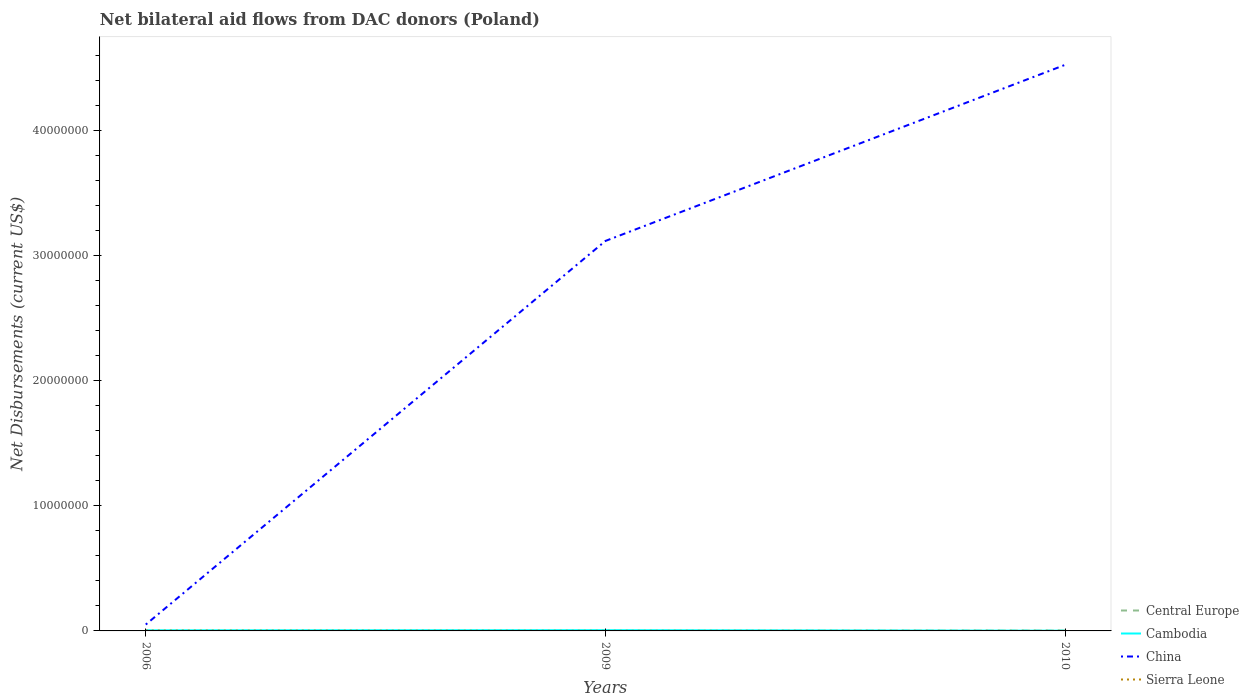How many different coloured lines are there?
Your answer should be compact. 4. Does the line corresponding to Cambodia intersect with the line corresponding to Central Europe?
Give a very brief answer. Yes. What is the total net bilateral aid flows in China in the graph?
Offer a very short reply. -1.41e+07. What is the difference between the highest and the second highest net bilateral aid flows in Cambodia?
Offer a very short reply. 4.00e+04. What is the difference between the highest and the lowest net bilateral aid flows in China?
Give a very brief answer. 2. How many lines are there?
Make the answer very short. 4. Are the values on the major ticks of Y-axis written in scientific E-notation?
Your response must be concise. No. Where does the legend appear in the graph?
Ensure brevity in your answer.  Bottom right. What is the title of the graph?
Ensure brevity in your answer.  Net bilateral aid flows from DAC donors (Poland). Does "Turks and Caicos Islands" appear as one of the legend labels in the graph?
Offer a terse response. No. What is the label or title of the Y-axis?
Give a very brief answer. Net Disbursements (current US$). What is the Net Disbursements (current US$) in Cambodia in 2006?
Give a very brief answer. 5.00e+04. What is the Net Disbursements (current US$) in China in 2006?
Offer a very short reply. 5.10e+05. What is the Net Disbursements (current US$) in Central Europe in 2009?
Your answer should be compact. 10000. What is the Net Disbursements (current US$) of China in 2009?
Your answer should be very brief. 3.12e+07. What is the Net Disbursements (current US$) of Central Europe in 2010?
Your answer should be compact. 3.00e+04. What is the Net Disbursements (current US$) in China in 2010?
Your answer should be very brief. 4.52e+07. What is the Net Disbursements (current US$) of Sierra Leone in 2010?
Give a very brief answer. 10000. Across all years, what is the maximum Net Disbursements (current US$) of China?
Provide a succinct answer. 4.52e+07. Across all years, what is the maximum Net Disbursements (current US$) of Sierra Leone?
Ensure brevity in your answer.  3.00e+04. Across all years, what is the minimum Net Disbursements (current US$) of Central Europe?
Your answer should be compact. 10000. Across all years, what is the minimum Net Disbursements (current US$) in China?
Your response must be concise. 5.10e+05. Across all years, what is the minimum Net Disbursements (current US$) in Sierra Leone?
Keep it short and to the point. 10000. What is the total Net Disbursements (current US$) of Central Europe in the graph?
Your answer should be compact. 5.00e+04. What is the total Net Disbursements (current US$) of Cambodia in the graph?
Offer a terse response. 1.30e+05. What is the total Net Disbursements (current US$) in China in the graph?
Provide a succinct answer. 7.69e+07. What is the total Net Disbursements (current US$) in Sierra Leone in the graph?
Your answer should be very brief. 5.00e+04. What is the difference between the Net Disbursements (current US$) in Cambodia in 2006 and that in 2009?
Give a very brief answer. -10000. What is the difference between the Net Disbursements (current US$) in China in 2006 and that in 2009?
Ensure brevity in your answer.  -3.06e+07. What is the difference between the Net Disbursements (current US$) of Cambodia in 2006 and that in 2010?
Your response must be concise. 3.00e+04. What is the difference between the Net Disbursements (current US$) in China in 2006 and that in 2010?
Offer a terse response. -4.47e+07. What is the difference between the Net Disbursements (current US$) in Central Europe in 2009 and that in 2010?
Make the answer very short. -2.00e+04. What is the difference between the Net Disbursements (current US$) in Cambodia in 2009 and that in 2010?
Offer a terse response. 4.00e+04. What is the difference between the Net Disbursements (current US$) in China in 2009 and that in 2010?
Give a very brief answer. -1.41e+07. What is the difference between the Net Disbursements (current US$) of Sierra Leone in 2009 and that in 2010?
Your answer should be compact. 0. What is the difference between the Net Disbursements (current US$) of Central Europe in 2006 and the Net Disbursements (current US$) of Cambodia in 2009?
Give a very brief answer. -5.00e+04. What is the difference between the Net Disbursements (current US$) of Central Europe in 2006 and the Net Disbursements (current US$) of China in 2009?
Keep it short and to the point. -3.12e+07. What is the difference between the Net Disbursements (current US$) in Cambodia in 2006 and the Net Disbursements (current US$) in China in 2009?
Offer a very short reply. -3.11e+07. What is the difference between the Net Disbursements (current US$) in Cambodia in 2006 and the Net Disbursements (current US$) in Sierra Leone in 2009?
Provide a succinct answer. 4.00e+04. What is the difference between the Net Disbursements (current US$) in China in 2006 and the Net Disbursements (current US$) in Sierra Leone in 2009?
Keep it short and to the point. 5.00e+05. What is the difference between the Net Disbursements (current US$) in Central Europe in 2006 and the Net Disbursements (current US$) in China in 2010?
Give a very brief answer. -4.52e+07. What is the difference between the Net Disbursements (current US$) of Central Europe in 2006 and the Net Disbursements (current US$) of Sierra Leone in 2010?
Your answer should be compact. 0. What is the difference between the Net Disbursements (current US$) in Cambodia in 2006 and the Net Disbursements (current US$) in China in 2010?
Offer a very short reply. -4.52e+07. What is the difference between the Net Disbursements (current US$) of Cambodia in 2006 and the Net Disbursements (current US$) of Sierra Leone in 2010?
Provide a short and direct response. 4.00e+04. What is the difference between the Net Disbursements (current US$) of China in 2006 and the Net Disbursements (current US$) of Sierra Leone in 2010?
Offer a very short reply. 5.00e+05. What is the difference between the Net Disbursements (current US$) of Central Europe in 2009 and the Net Disbursements (current US$) of China in 2010?
Provide a succinct answer. -4.52e+07. What is the difference between the Net Disbursements (current US$) in Central Europe in 2009 and the Net Disbursements (current US$) in Sierra Leone in 2010?
Provide a succinct answer. 0. What is the difference between the Net Disbursements (current US$) of Cambodia in 2009 and the Net Disbursements (current US$) of China in 2010?
Make the answer very short. -4.52e+07. What is the difference between the Net Disbursements (current US$) in China in 2009 and the Net Disbursements (current US$) in Sierra Leone in 2010?
Provide a succinct answer. 3.12e+07. What is the average Net Disbursements (current US$) of Central Europe per year?
Offer a very short reply. 1.67e+04. What is the average Net Disbursements (current US$) in Cambodia per year?
Offer a terse response. 4.33e+04. What is the average Net Disbursements (current US$) of China per year?
Make the answer very short. 2.56e+07. What is the average Net Disbursements (current US$) in Sierra Leone per year?
Keep it short and to the point. 1.67e+04. In the year 2006, what is the difference between the Net Disbursements (current US$) in Central Europe and Net Disbursements (current US$) in Cambodia?
Make the answer very short. -4.00e+04. In the year 2006, what is the difference between the Net Disbursements (current US$) in Central Europe and Net Disbursements (current US$) in China?
Your response must be concise. -5.00e+05. In the year 2006, what is the difference between the Net Disbursements (current US$) in Central Europe and Net Disbursements (current US$) in Sierra Leone?
Provide a succinct answer. -2.00e+04. In the year 2006, what is the difference between the Net Disbursements (current US$) in Cambodia and Net Disbursements (current US$) in China?
Offer a terse response. -4.60e+05. In the year 2006, what is the difference between the Net Disbursements (current US$) of Cambodia and Net Disbursements (current US$) of Sierra Leone?
Your answer should be very brief. 2.00e+04. In the year 2006, what is the difference between the Net Disbursements (current US$) in China and Net Disbursements (current US$) in Sierra Leone?
Provide a short and direct response. 4.80e+05. In the year 2009, what is the difference between the Net Disbursements (current US$) in Central Europe and Net Disbursements (current US$) in Cambodia?
Your answer should be compact. -5.00e+04. In the year 2009, what is the difference between the Net Disbursements (current US$) in Central Europe and Net Disbursements (current US$) in China?
Offer a very short reply. -3.12e+07. In the year 2009, what is the difference between the Net Disbursements (current US$) of Central Europe and Net Disbursements (current US$) of Sierra Leone?
Give a very brief answer. 0. In the year 2009, what is the difference between the Net Disbursements (current US$) of Cambodia and Net Disbursements (current US$) of China?
Give a very brief answer. -3.11e+07. In the year 2009, what is the difference between the Net Disbursements (current US$) in China and Net Disbursements (current US$) in Sierra Leone?
Provide a succinct answer. 3.12e+07. In the year 2010, what is the difference between the Net Disbursements (current US$) in Central Europe and Net Disbursements (current US$) in China?
Keep it short and to the point. -4.52e+07. In the year 2010, what is the difference between the Net Disbursements (current US$) of Cambodia and Net Disbursements (current US$) of China?
Your answer should be compact. -4.52e+07. In the year 2010, what is the difference between the Net Disbursements (current US$) in Cambodia and Net Disbursements (current US$) in Sierra Leone?
Give a very brief answer. 10000. In the year 2010, what is the difference between the Net Disbursements (current US$) of China and Net Disbursements (current US$) of Sierra Leone?
Your response must be concise. 4.52e+07. What is the ratio of the Net Disbursements (current US$) in Central Europe in 2006 to that in 2009?
Make the answer very short. 1. What is the ratio of the Net Disbursements (current US$) of China in 2006 to that in 2009?
Ensure brevity in your answer.  0.02. What is the ratio of the Net Disbursements (current US$) of Central Europe in 2006 to that in 2010?
Your answer should be very brief. 0.33. What is the ratio of the Net Disbursements (current US$) in China in 2006 to that in 2010?
Your answer should be compact. 0.01. What is the ratio of the Net Disbursements (current US$) of Sierra Leone in 2006 to that in 2010?
Your response must be concise. 3. What is the ratio of the Net Disbursements (current US$) in Cambodia in 2009 to that in 2010?
Your response must be concise. 3. What is the ratio of the Net Disbursements (current US$) in China in 2009 to that in 2010?
Keep it short and to the point. 0.69. What is the ratio of the Net Disbursements (current US$) of Sierra Leone in 2009 to that in 2010?
Your answer should be very brief. 1. What is the difference between the highest and the second highest Net Disbursements (current US$) of Cambodia?
Your response must be concise. 10000. What is the difference between the highest and the second highest Net Disbursements (current US$) of China?
Give a very brief answer. 1.41e+07. What is the difference between the highest and the lowest Net Disbursements (current US$) of China?
Provide a succinct answer. 4.47e+07. 